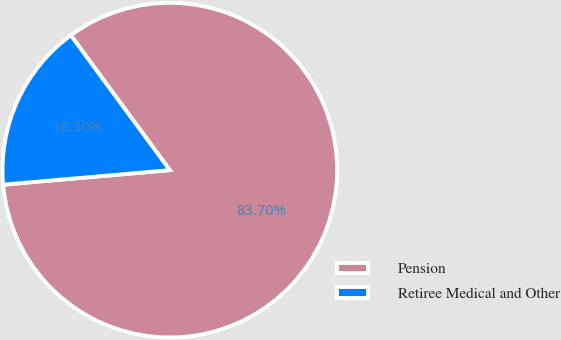Convert chart to OTSL. <chart><loc_0><loc_0><loc_500><loc_500><pie_chart><fcel>Pension<fcel>Retiree Medical and Other<nl><fcel>83.7%<fcel>16.3%<nl></chart> 